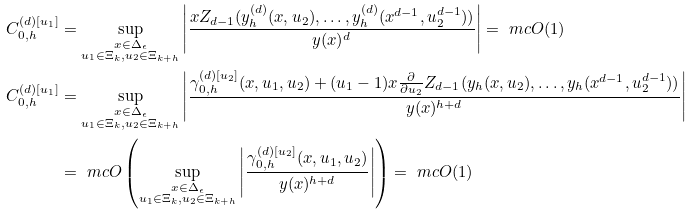<formula> <loc_0><loc_0><loc_500><loc_500>C _ { 0 , h } ^ { ( d ) [ u _ { 1 } ] } & = \sup _ { \substack { x \in \Delta _ { \epsilon } \\ u _ { 1 } \in \Xi _ { k } , u _ { 2 } \in \Xi _ { k + h } } } \left | \frac { x Z _ { d - 1 } ( y _ { h } ^ { ( d ) } ( x , u _ { 2 } ) , \dots , y _ { h } ^ { ( d ) } ( x ^ { d - 1 } , u _ { 2 } ^ { d - 1 } ) ) } { y ( x ) ^ { d } } \right | = \ m c { O } ( 1 ) \\ C _ { 0 , h } ^ { ( d ) [ u _ { 1 } ] } & = \sup _ { \substack { x \in \Delta _ { \epsilon } \\ u _ { 1 } \in \Xi _ { k } , u _ { 2 } \in \Xi _ { k + h } } } \left | \frac { \gamma _ { 0 , h } ^ { ( d ) [ u _ { 2 } ] } ( x , u _ { 1 } , u _ { 2 } ) + ( u _ { 1 } - 1 ) x \frac { \partial } { \partial u _ { 2 } } Z _ { d - 1 } ( y _ { h } ( x , u _ { 2 } ) , \dots , y _ { h } ( x ^ { d - 1 } , u _ { 2 } ^ { d - 1 } ) ) } { y ( x ) ^ { h + d } } \right | \\ & = \ m c { O } \left ( \sup _ { \substack { x \in \Delta _ { \epsilon } \\ u _ { 1 } \in \Xi _ { k } , u _ { 2 } \in \Xi _ { k + h } } } \left | \frac { \gamma _ { 0 , h } ^ { ( d ) [ u _ { 2 } ] } ( x , u _ { 1 } , u _ { 2 } ) } { y ( x ) ^ { h + d } } \right | \right ) = \ m c { O } ( 1 )</formula> 